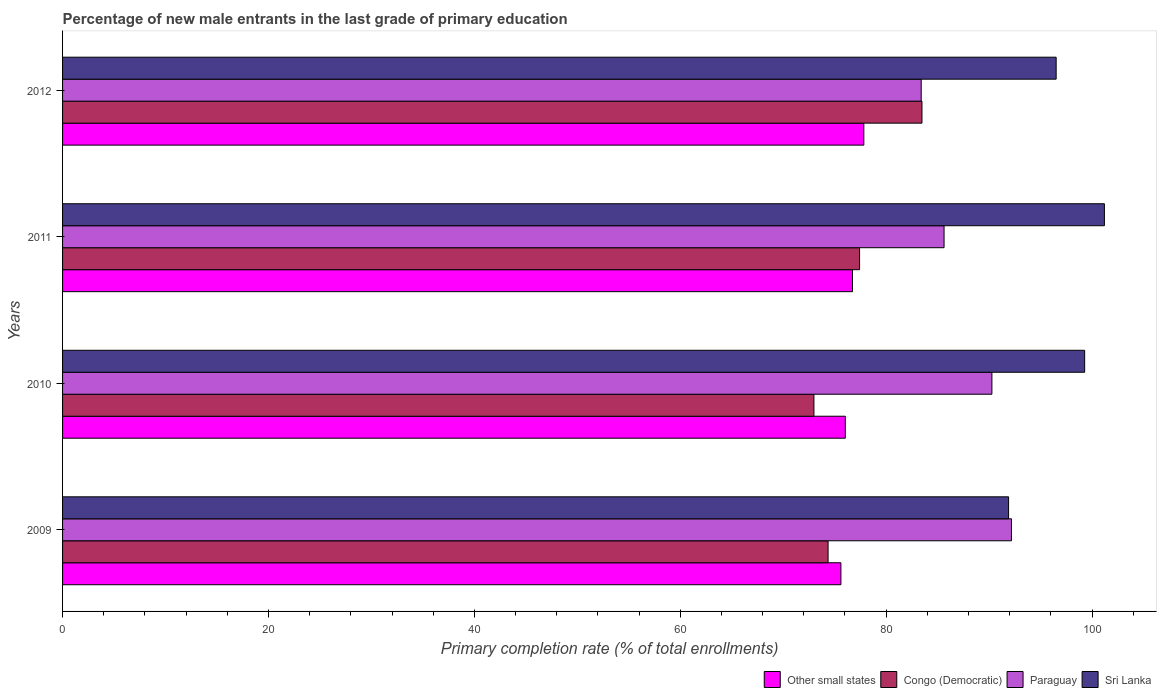Are the number of bars on each tick of the Y-axis equal?
Your answer should be compact. Yes. How many bars are there on the 3rd tick from the bottom?
Give a very brief answer. 4. What is the percentage of new male entrants in Sri Lanka in 2009?
Your answer should be compact. 91.89. Across all years, what is the maximum percentage of new male entrants in Other small states?
Your answer should be very brief. 77.83. Across all years, what is the minimum percentage of new male entrants in Congo (Democratic)?
Your answer should be very brief. 72.99. In which year was the percentage of new male entrants in Paraguay maximum?
Your answer should be very brief. 2009. What is the total percentage of new male entrants in Paraguay in the graph?
Provide a short and direct response. 351.48. What is the difference between the percentage of new male entrants in Sri Lanka in 2010 and that in 2011?
Your answer should be compact. -1.92. What is the difference between the percentage of new male entrants in Sri Lanka in 2010 and the percentage of new male entrants in Paraguay in 2011?
Your answer should be very brief. 13.66. What is the average percentage of new male entrants in Other small states per year?
Make the answer very short. 76.55. In the year 2009, what is the difference between the percentage of new male entrants in Congo (Democratic) and percentage of new male entrants in Other small states?
Your response must be concise. -1.25. In how many years, is the percentage of new male entrants in Congo (Democratic) greater than 64 %?
Keep it short and to the point. 4. What is the ratio of the percentage of new male entrants in Sri Lanka in 2011 to that in 2012?
Provide a short and direct response. 1.05. Is the percentage of new male entrants in Congo (Democratic) in 2010 less than that in 2011?
Your answer should be very brief. Yes. What is the difference between the highest and the second highest percentage of new male entrants in Sri Lanka?
Your answer should be very brief. 1.92. What is the difference between the highest and the lowest percentage of new male entrants in Sri Lanka?
Provide a succinct answer. 9.31. Is the sum of the percentage of new male entrants in Paraguay in 2009 and 2012 greater than the maximum percentage of new male entrants in Congo (Democratic) across all years?
Your answer should be very brief. Yes. What does the 2nd bar from the top in 2009 represents?
Your response must be concise. Paraguay. What does the 4th bar from the bottom in 2010 represents?
Your response must be concise. Sri Lanka. Is it the case that in every year, the sum of the percentage of new male entrants in Other small states and percentage of new male entrants in Congo (Democratic) is greater than the percentage of new male entrants in Paraguay?
Provide a short and direct response. Yes. Are all the bars in the graph horizontal?
Offer a very short reply. Yes. Are the values on the major ticks of X-axis written in scientific E-notation?
Provide a succinct answer. No. Does the graph contain any zero values?
Offer a terse response. No. Where does the legend appear in the graph?
Provide a succinct answer. Bottom right. How many legend labels are there?
Keep it short and to the point. 4. What is the title of the graph?
Make the answer very short. Percentage of new male entrants in the last grade of primary education. What is the label or title of the X-axis?
Provide a succinct answer. Primary completion rate (% of total enrollments). What is the label or title of the Y-axis?
Make the answer very short. Years. What is the Primary completion rate (% of total enrollments) in Other small states in 2009?
Give a very brief answer. 75.61. What is the Primary completion rate (% of total enrollments) of Congo (Democratic) in 2009?
Your answer should be compact. 74.36. What is the Primary completion rate (% of total enrollments) of Paraguay in 2009?
Provide a short and direct response. 92.17. What is the Primary completion rate (% of total enrollments) of Sri Lanka in 2009?
Provide a short and direct response. 91.89. What is the Primary completion rate (% of total enrollments) in Other small states in 2010?
Ensure brevity in your answer.  76.03. What is the Primary completion rate (% of total enrollments) in Congo (Democratic) in 2010?
Your answer should be compact. 72.99. What is the Primary completion rate (% of total enrollments) of Paraguay in 2010?
Keep it short and to the point. 90.27. What is the Primary completion rate (% of total enrollments) in Sri Lanka in 2010?
Ensure brevity in your answer.  99.28. What is the Primary completion rate (% of total enrollments) in Other small states in 2011?
Make the answer very short. 76.73. What is the Primary completion rate (% of total enrollments) of Congo (Democratic) in 2011?
Give a very brief answer. 77.42. What is the Primary completion rate (% of total enrollments) of Paraguay in 2011?
Make the answer very short. 85.63. What is the Primary completion rate (% of total enrollments) of Sri Lanka in 2011?
Make the answer very short. 101.2. What is the Primary completion rate (% of total enrollments) in Other small states in 2012?
Offer a very short reply. 77.83. What is the Primary completion rate (% of total enrollments) of Congo (Democratic) in 2012?
Your answer should be compact. 83.48. What is the Primary completion rate (% of total enrollments) of Paraguay in 2012?
Give a very brief answer. 83.41. What is the Primary completion rate (% of total enrollments) in Sri Lanka in 2012?
Give a very brief answer. 96.51. Across all years, what is the maximum Primary completion rate (% of total enrollments) in Other small states?
Provide a short and direct response. 77.83. Across all years, what is the maximum Primary completion rate (% of total enrollments) of Congo (Democratic)?
Your response must be concise. 83.48. Across all years, what is the maximum Primary completion rate (% of total enrollments) in Paraguay?
Your response must be concise. 92.17. Across all years, what is the maximum Primary completion rate (% of total enrollments) of Sri Lanka?
Provide a short and direct response. 101.2. Across all years, what is the minimum Primary completion rate (% of total enrollments) in Other small states?
Your response must be concise. 75.61. Across all years, what is the minimum Primary completion rate (% of total enrollments) in Congo (Democratic)?
Make the answer very short. 72.99. Across all years, what is the minimum Primary completion rate (% of total enrollments) of Paraguay?
Ensure brevity in your answer.  83.41. Across all years, what is the minimum Primary completion rate (% of total enrollments) in Sri Lanka?
Provide a succinct answer. 91.89. What is the total Primary completion rate (% of total enrollments) in Other small states in the graph?
Ensure brevity in your answer.  306.21. What is the total Primary completion rate (% of total enrollments) in Congo (Democratic) in the graph?
Ensure brevity in your answer.  308.25. What is the total Primary completion rate (% of total enrollments) in Paraguay in the graph?
Ensure brevity in your answer.  351.48. What is the total Primary completion rate (% of total enrollments) of Sri Lanka in the graph?
Your response must be concise. 388.89. What is the difference between the Primary completion rate (% of total enrollments) of Other small states in 2009 and that in 2010?
Provide a succinct answer. -0.43. What is the difference between the Primary completion rate (% of total enrollments) of Congo (Democratic) in 2009 and that in 2010?
Give a very brief answer. 1.38. What is the difference between the Primary completion rate (% of total enrollments) in Paraguay in 2009 and that in 2010?
Your answer should be compact. 1.9. What is the difference between the Primary completion rate (% of total enrollments) of Sri Lanka in 2009 and that in 2010?
Keep it short and to the point. -7.39. What is the difference between the Primary completion rate (% of total enrollments) of Other small states in 2009 and that in 2011?
Your response must be concise. -1.13. What is the difference between the Primary completion rate (% of total enrollments) in Congo (Democratic) in 2009 and that in 2011?
Your answer should be very brief. -3.06. What is the difference between the Primary completion rate (% of total enrollments) of Paraguay in 2009 and that in 2011?
Offer a terse response. 6.55. What is the difference between the Primary completion rate (% of total enrollments) of Sri Lanka in 2009 and that in 2011?
Make the answer very short. -9.31. What is the difference between the Primary completion rate (% of total enrollments) of Other small states in 2009 and that in 2012?
Make the answer very short. -2.23. What is the difference between the Primary completion rate (% of total enrollments) of Congo (Democratic) in 2009 and that in 2012?
Provide a short and direct response. -9.12. What is the difference between the Primary completion rate (% of total enrollments) of Paraguay in 2009 and that in 2012?
Keep it short and to the point. 8.77. What is the difference between the Primary completion rate (% of total enrollments) in Sri Lanka in 2009 and that in 2012?
Offer a terse response. -4.62. What is the difference between the Primary completion rate (% of total enrollments) in Other small states in 2010 and that in 2011?
Give a very brief answer. -0.7. What is the difference between the Primary completion rate (% of total enrollments) of Congo (Democratic) in 2010 and that in 2011?
Your answer should be compact. -4.43. What is the difference between the Primary completion rate (% of total enrollments) of Paraguay in 2010 and that in 2011?
Provide a succinct answer. 4.65. What is the difference between the Primary completion rate (% of total enrollments) in Sri Lanka in 2010 and that in 2011?
Your answer should be compact. -1.92. What is the difference between the Primary completion rate (% of total enrollments) in Other small states in 2010 and that in 2012?
Ensure brevity in your answer.  -1.8. What is the difference between the Primary completion rate (% of total enrollments) in Congo (Democratic) in 2010 and that in 2012?
Your response must be concise. -10.5. What is the difference between the Primary completion rate (% of total enrollments) in Paraguay in 2010 and that in 2012?
Keep it short and to the point. 6.87. What is the difference between the Primary completion rate (% of total enrollments) of Sri Lanka in 2010 and that in 2012?
Offer a very short reply. 2.77. What is the difference between the Primary completion rate (% of total enrollments) of Other small states in 2011 and that in 2012?
Your response must be concise. -1.1. What is the difference between the Primary completion rate (% of total enrollments) in Congo (Democratic) in 2011 and that in 2012?
Provide a short and direct response. -6.06. What is the difference between the Primary completion rate (% of total enrollments) in Paraguay in 2011 and that in 2012?
Offer a very short reply. 2.22. What is the difference between the Primary completion rate (% of total enrollments) in Sri Lanka in 2011 and that in 2012?
Keep it short and to the point. 4.69. What is the difference between the Primary completion rate (% of total enrollments) of Other small states in 2009 and the Primary completion rate (% of total enrollments) of Congo (Democratic) in 2010?
Keep it short and to the point. 2.62. What is the difference between the Primary completion rate (% of total enrollments) of Other small states in 2009 and the Primary completion rate (% of total enrollments) of Paraguay in 2010?
Your answer should be compact. -14.67. What is the difference between the Primary completion rate (% of total enrollments) of Other small states in 2009 and the Primary completion rate (% of total enrollments) of Sri Lanka in 2010?
Keep it short and to the point. -23.68. What is the difference between the Primary completion rate (% of total enrollments) of Congo (Democratic) in 2009 and the Primary completion rate (% of total enrollments) of Paraguay in 2010?
Your answer should be very brief. -15.91. What is the difference between the Primary completion rate (% of total enrollments) of Congo (Democratic) in 2009 and the Primary completion rate (% of total enrollments) of Sri Lanka in 2010?
Offer a very short reply. -24.92. What is the difference between the Primary completion rate (% of total enrollments) in Paraguay in 2009 and the Primary completion rate (% of total enrollments) in Sri Lanka in 2010?
Your answer should be compact. -7.11. What is the difference between the Primary completion rate (% of total enrollments) in Other small states in 2009 and the Primary completion rate (% of total enrollments) in Congo (Democratic) in 2011?
Offer a terse response. -1.81. What is the difference between the Primary completion rate (% of total enrollments) of Other small states in 2009 and the Primary completion rate (% of total enrollments) of Paraguay in 2011?
Your response must be concise. -10.02. What is the difference between the Primary completion rate (% of total enrollments) in Other small states in 2009 and the Primary completion rate (% of total enrollments) in Sri Lanka in 2011?
Your answer should be very brief. -25.59. What is the difference between the Primary completion rate (% of total enrollments) of Congo (Democratic) in 2009 and the Primary completion rate (% of total enrollments) of Paraguay in 2011?
Give a very brief answer. -11.27. What is the difference between the Primary completion rate (% of total enrollments) of Congo (Democratic) in 2009 and the Primary completion rate (% of total enrollments) of Sri Lanka in 2011?
Offer a very short reply. -26.84. What is the difference between the Primary completion rate (% of total enrollments) in Paraguay in 2009 and the Primary completion rate (% of total enrollments) in Sri Lanka in 2011?
Your response must be concise. -9.03. What is the difference between the Primary completion rate (% of total enrollments) in Other small states in 2009 and the Primary completion rate (% of total enrollments) in Congo (Democratic) in 2012?
Your answer should be compact. -7.87. What is the difference between the Primary completion rate (% of total enrollments) in Other small states in 2009 and the Primary completion rate (% of total enrollments) in Paraguay in 2012?
Keep it short and to the point. -7.8. What is the difference between the Primary completion rate (% of total enrollments) in Other small states in 2009 and the Primary completion rate (% of total enrollments) in Sri Lanka in 2012?
Your answer should be very brief. -20.91. What is the difference between the Primary completion rate (% of total enrollments) in Congo (Democratic) in 2009 and the Primary completion rate (% of total enrollments) in Paraguay in 2012?
Ensure brevity in your answer.  -9.05. What is the difference between the Primary completion rate (% of total enrollments) in Congo (Democratic) in 2009 and the Primary completion rate (% of total enrollments) in Sri Lanka in 2012?
Your answer should be very brief. -22.15. What is the difference between the Primary completion rate (% of total enrollments) in Paraguay in 2009 and the Primary completion rate (% of total enrollments) in Sri Lanka in 2012?
Ensure brevity in your answer.  -4.34. What is the difference between the Primary completion rate (% of total enrollments) of Other small states in 2010 and the Primary completion rate (% of total enrollments) of Congo (Democratic) in 2011?
Your answer should be compact. -1.38. What is the difference between the Primary completion rate (% of total enrollments) of Other small states in 2010 and the Primary completion rate (% of total enrollments) of Paraguay in 2011?
Ensure brevity in your answer.  -9.59. What is the difference between the Primary completion rate (% of total enrollments) of Other small states in 2010 and the Primary completion rate (% of total enrollments) of Sri Lanka in 2011?
Your response must be concise. -25.17. What is the difference between the Primary completion rate (% of total enrollments) in Congo (Democratic) in 2010 and the Primary completion rate (% of total enrollments) in Paraguay in 2011?
Your response must be concise. -12.64. What is the difference between the Primary completion rate (% of total enrollments) in Congo (Democratic) in 2010 and the Primary completion rate (% of total enrollments) in Sri Lanka in 2011?
Your response must be concise. -28.22. What is the difference between the Primary completion rate (% of total enrollments) in Paraguay in 2010 and the Primary completion rate (% of total enrollments) in Sri Lanka in 2011?
Offer a very short reply. -10.93. What is the difference between the Primary completion rate (% of total enrollments) in Other small states in 2010 and the Primary completion rate (% of total enrollments) in Congo (Democratic) in 2012?
Your answer should be very brief. -7.45. What is the difference between the Primary completion rate (% of total enrollments) in Other small states in 2010 and the Primary completion rate (% of total enrollments) in Paraguay in 2012?
Your response must be concise. -7.37. What is the difference between the Primary completion rate (% of total enrollments) in Other small states in 2010 and the Primary completion rate (% of total enrollments) in Sri Lanka in 2012?
Keep it short and to the point. -20.48. What is the difference between the Primary completion rate (% of total enrollments) in Congo (Democratic) in 2010 and the Primary completion rate (% of total enrollments) in Paraguay in 2012?
Your answer should be very brief. -10.42. What is the difference between the Primary completion rate (% of total enrollments) of Congo (Democratic) in 2010 and the Primary completion rate (% of total enrollments) of Sri Lanka in 2012?
Keep it short and to the point. -23.53. What is the difference between the Primary completion rate (% of total enrollments) of Paraguay in 2010 and the Primary completion rate (% of total enrollments) of Sri Lanka in 2012?
Your answer should be compact. -6.24. What is the difference between the Primary completion rate (% of total enrollments) of Other small states in 2011 and the Primary completion rate (% of total enrollments) of Congo (Democratic) in 2012?
Keep it short and to the point. -6.75. What is the difference between the Primary completion rate (% of total enrollments) of Other small states in 2011 and the Primary completion rate (% of total enrollments) of Paraguay in 2012?
Your response must be concise. -6.67. What is the difference between the Primary completion rate (% of total enrollments) in Other small states in 2011 and the Primary completion rate (% of total enrollments) in Sri Lanka in 2012?
Offer a very short reply. -19.78. What is the difference between the Primary completion rate (% of total enrollments) in Congo (Democratic) in 2011 and the Primary completion rate (% of total enrollments) in Paraguay in 2012?
Give a very brief answer. -5.99. What is the difference between the Primary completion rate (% of total enrollments) of Congo (Democratic) in 2011 and the Primary completion rate (% of total enrollments) of Sri Lanka in 2012?
Your response must be concise. -19.1. What is the difference between the Primary completion rate (% of total enrollments) of Paraguay in 2011 and the Primary completion rate (% of total enrollments) of Sri Lanka in 2012?
Provide a succinct answer. -10.89. What is the average Primary completion rate (% of total enrollments) in Other small states per year?
Your response must be concise. 76.55. What is the average Primary completion rate (% of total enrollments) of Congo (Democratic) per year?
Ensure brevity in your answer.  77.06. What is the average Primary completion rate (% of total enrollments) in Paraguay per year?
Ensure brevity in your answer.  87.87. What is the average Primary completion rate (% of total enrollments) of Sri Lanka per year?
Provide a short and direct response. 97.22. In the year 2009, what is the difference between the Primary completion rate (% of total enrollments) in Other small states and Primary completion rate (% of total enrollments) in Congo (Democratic)?
Offer a terse response. 1.25. In the year 2009, what is the difference between the Primary completion rate (% of total enrollments) in Other small states and Primary completion rate (% of total enrollments) in Paraguay?
Offer a very short reply. -16.57. In the year 2009, what is the difference between the Primary completion rate (% of total enrollments) in Other small states and Primary completion rate (% of total enrollments) in Sri Lanka?
Your answer should be compact. -16.29. In the year 2009, what is the difference between the Primary completion rate (% of total enrollments) in Congo (Democratic) and Primary completion rate (% of total enrollments) in Paraguay?
Provide a short and direct response. -17.81. In the year 2009, what is the difference between the Primary completion rate (% of total enrollments) of Congo (Democratic) and Primary completion rate (% of total enrollments) of Sri Lanka?
Offer a very short reply. -17.53. In the year 2009, what is the difference between the Primary completion rate (% of total enrollments) of Paraguay and Primary completion rate (% of total enrollments) of Sri Lanka?
Offer a very short reply. 0.28. In the year 2010, what is the difference between the Primary completion rate (% of total enrollments) of Other small states and Primary completion rate (% of total enrollments) of Congo (Democratic)?
Give a very brief answer. 3.05. In the year 2010, what is the difference between the Primary completion rate (% of total enrollments) of Other small states and Primary completion rate (% of total enrollments) of Paraguay?
Offer a very short reply. -14.24. In the year 2010, what is the difference between the Primary completion rate (% of total enrollments) in Other small states and Primary completion rate (% of total enrollments) in Sri Lanka?
Make the answer very short. -23.25. In the year 2010, what is the difference between the Primary completion rate (% of total enrollments) in Congo (Democratic) and Primary completion rate (% of total enrollments) in Paraguay?
Your answer should be compact. -17.29. In the year 2010, what is the difference between the Primary completion rate (% of total enrollments) in Congo (Democratic) and Primary completion rate (% of total enrollments) in Sri Lanka?
Provide a short and direct response. -26.3. In the year 2010, what is the difference between the Primary completion rate (% of total enrollments) in Paraguay and Primary completion rate (% of total enrollments) in Sri Lanka?
Ensure brevity in your answer.  -9.01. In the year 2011, what is the difference between the Primary completion rate (% of total enrollments) in Other small states and Primary completion rate (% of total enrollments) in Congo (Democratic)?
Provide a succinct answer. -0.69. In the year 2011, what is the difference between the Primary completion rate (% of total enrollments) in Other small states and Primary completion rate (% of total enrollments) in Paraguay?
Provide a succinct answer. -8.89. In the year 2011, what is the difference between the Primary completion rate (% of total enrollments) in Other small states and Primary completion rate (% of total enrollments) in Sri Lanka?
Provide a succinct answer. -24.47. In the year 2011, what is the difference between the Primary completion rate (% of total enrollments) of Congo (Democratic) and Primary completion rate (% of total enrollments) of Paraguay?
Your answer should be very brief. -8.21. In the year 2011, what is the difference between the Primary completion rate (% of total enrollments) in Congo (Democratic) and Primary completion rate (% of total enrollments) in Sri Lanka?
Your answer should be compact. -23.78. In the year 2011, what is the difference between the Primary completion rate (% of total enrollments) of Paraguay and Primary completion rate (% of total enrollments) of Sri Lanka?
Offer a very short reply. -15.57. In the year 2012, what is the difference between the Primary completion rate (% of total enrollments) in Other small states and Primary completion rate (% of total enrollments) in Congo (Democratic)?
Give a very brief answer. -5.65. In the year 2012, what is the difference between the Primary completion rate (% of total enrollments) of Other small states and Primary completion rate (% of total enrollments) of Paraguay?
Provide a short and direct response. -5.57. In the year 2012, what is the difference between the Primary completion rate (% of total enrollments) in Other small states and Primary completion rate (% of total enrollments) in Sri Lanka?
Keep it short and to the point. -18.68. In the year 2012, what is the difference between the Primary completion rate (% of total enrollments) in Congo (Democratic) and Primary completion rate (% of total enrollments) in Paraguay?
Ensure brevity in your answer.  0.07. In the year 2012, what is the difference between the Primary completion rate (% of total enrollments) in Congo (Democratic) and Primary completion rate (% of total enrollments) in Sri Lanka?
Ensure brevity in your answer.  -13.03. In the year 2012, what is the difference between the Primary completion rate (% of total enrollments) of Paraguay and Primary completion rate (% of total enrollments) of Sri Lanka?
Ensure brevity in your answer.  -13.11. What is the ratio of the Primary completion rate (% of total enrollments) in Other small states in 2009 to that in 2010?
Keep it short and to the point. 0.99. What is the ratio of the Primary completion rate (% of total enrollments) in Congo (Democratic) in 2009 to that in 2010?
Give a very brief answer. 1.02. What is the ratio of the Primary completion rate (% of total enrollments) in Sri Lanka in 2009 to that in 2010?
Your answer should be very brief. 0.93. What is the ratio of the Primary completion rate (% of total enrollments) of Other small states in 2009 to that in 2011?
Offer a terse response. 0.99. What is the ratio of the Primary completion rate (% of total enrollments) in Congo (Democratic) in 2009 to that in 2011?
Offer a terse response. 0.96. What is the ratio of the Primary completion rate (% of total enrollments) in Paraguay in 2009 to that in 2011?
Give a very brief answer. 1.08. What is the ratio of the Primary completion rate (% of total enrollments) of Sri Lanka in 2009 to that in 2011?
Your answer should be very brief. 0.91. What is the ratio of the Primary completion rate (% of total enrollments) in Other small states in 2009 to that in 2012?
Your answer should be very brief. 0.97. What is the ratio of the Primary completion rate (% of total enrollments) of Congo (Democratic) in 2009 to that in 2012?
Make the answer very short. 0.89. What is the ratio of the Primary completion rate (% of total enrollments) of Paraguay in 2009 to that in 2012?
Your answer should be very brief. 1.11. What is the ratio of the Primary completion rate (% of total enrollments) of Sri Lanka in 2009 to that in 2012?
Your response must be concise. 0.95. What is the ratio of the Primary completion rate (% of total enrollments) of Other small states in 2010 to that in 2011?
Your response must be concise. 0.99. What is the ratio of the Primary completion rate (% of total enrollments) of Congo (Democratic) in 2010 to that in 2011?
Your answer should be very brief. 0.94. What is the ratio of the Primary completion rate (% of total enrollments) in Paraguay in 2010 to that in 2011?
Keep it short and to the point. 1.05. What is the ratio of the Primary completion rate (% of total enrollments) in Other small states in 2010 to that in 2012?
Offer a very short reply. 0.98. What is the ratio of the Primary completion rate (% of total enrollments) in Congo (Democratic) in 2010 to that in 2012?
Your answer should be very brief. 0.87. What is the ratio of the Primary completion rate (% of total enrollments) in Paraguay in 2010 to that in 2012?
Offer a terse response. 1.08. What is the ratio of the Primary completion rate (% of total enrollments) in Sri Lanka in 2010 to that in 2012?
Make the answer very short. 1.03. What is the ratio of the Primary completion rate (% of total enrollments) of Other small states in 2011 to that in 2012?
Offer a very short reply. 0.99. What is the ratio of the Primary completion rate (% of total enrollments) in Congo (Democratic) in 2011 to that in 2012?
Your response must be concise. 0.93. What is the ratio of the Primary completion rate (% of total enrollments) in Paraguay in 2011 to that in 2012?
Provide a succinct answer. 1.03. What is the ratio of the Primary completion rate (% of total enrollments) of Sri Lanka in 2011 to that in 2012?
Keep it short and to the point. 1.05. What is the difference between the highest and the second highest Primary completion rate (% of total enrollments) in Other small states?
Provide a short and direct response. 1.1. What is the difference between the highest and the second highest Primary completion rate (% of total enrollments) in Congo (Democratic)?
Offer a terse response. 6.06. What is the difference between the highest and the second highest Primary completion rate (% of total enrollments) of Paraguay?
Provide a short and direct response. 1.9. What is the difference between the highest and the second highest Primary completion rate (% of total enrollments) in Sri Lanka?
Your answer should be very brief. 1.92. What is the difference between the highest and the lowest Primary completion rate (% of total enrollments) in Other small states?
Your response must be concise. 2.23. What is the difference between the highest and the lowest Primary completion rate (% of total enrollments) of Congo (Democratic)?
Keep it short and to the point. 10.5. What is the difference between the highest and the lowest Primary completion rate (% of total enrollments) of Paraguay?
Make the answer very short. 8.77. What is the difference between the highest and the lowest Primary completion rate (% of total enrollments) in Sri Lanka?
Provide a short and direct response. 9.31. 